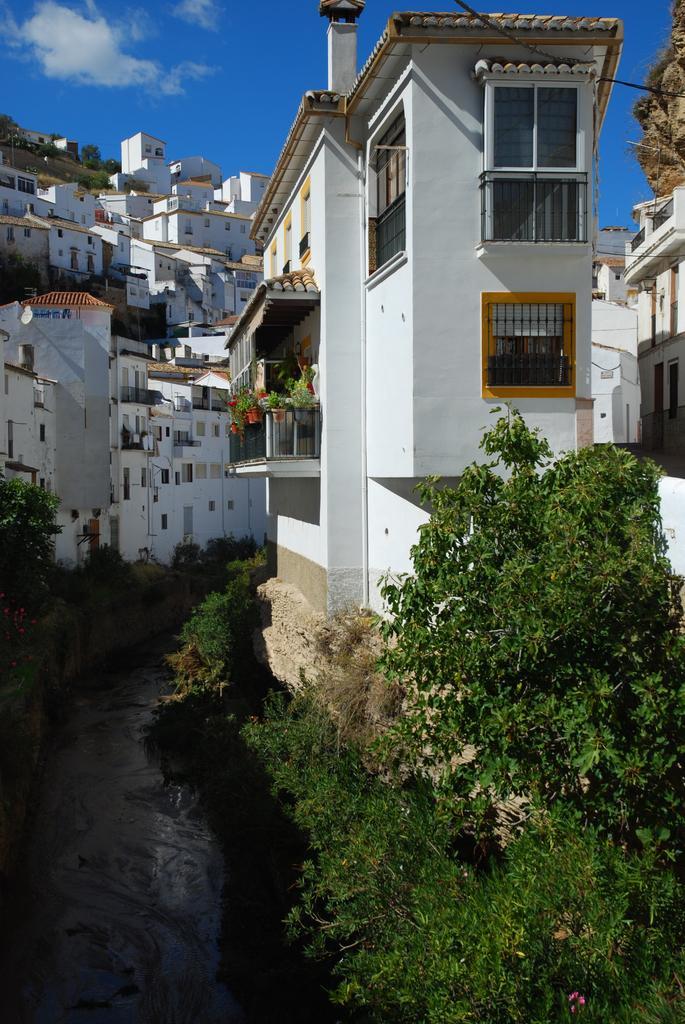Describe this image in one or two sentences. As we can see in the image there are trees, plants, water, buildings and hill. On the top there is sky and clouds. 